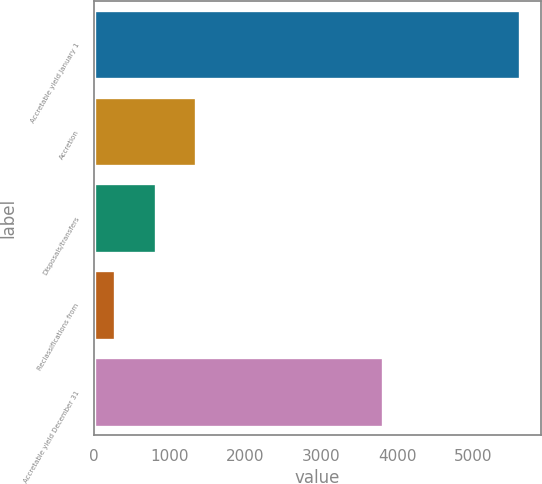Convert chart to OTSL. <chart><loc_0><loc_0><loc_500><loc_500><bar_chart><fcel>Accretable yield January 1<fcel>Accretion<fcel>Disposals/transfers<fcel>Reclassifications from<fcel>Accretable yield December 31<nl><fcel>5608<fcel>1351.2<fcel>819.1<fcel>287<fcel>3805<nl></chart> 